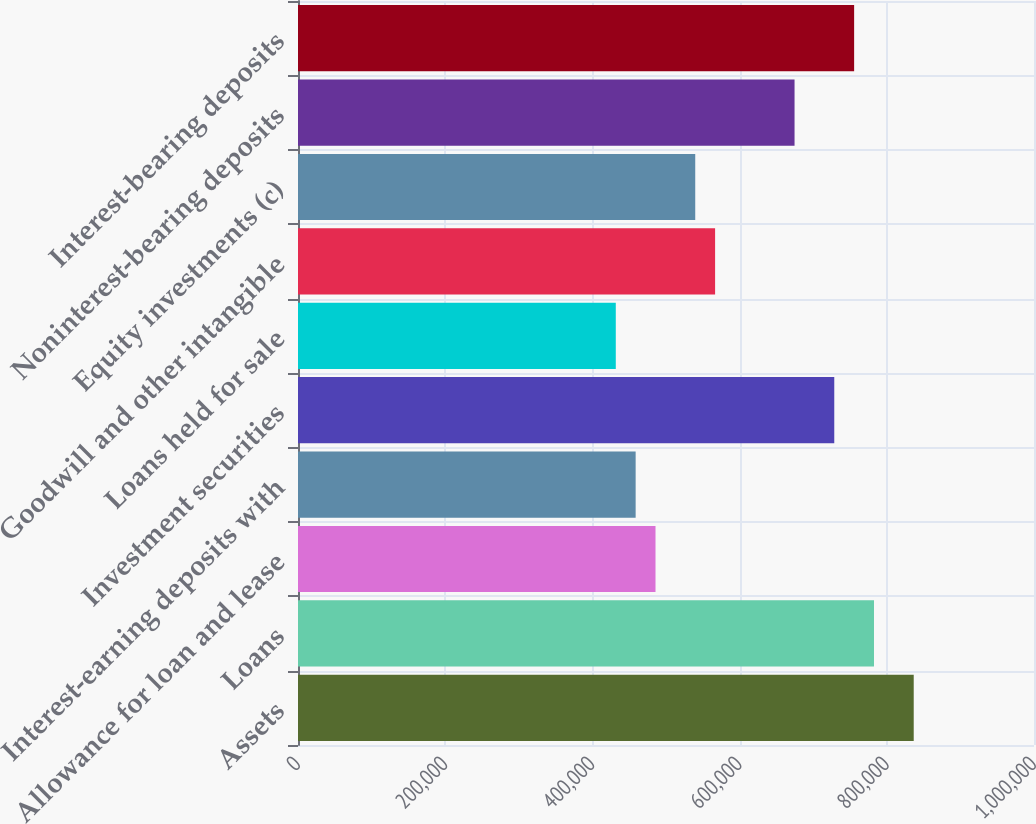<chart> <loc_0><loc_0><loc_500><loc_500><bar_chart><fcel>Assets<fcel>Loans<fcel>Allowance for loan and lease<fcel>Interest-earning deposits with<fcel>Investment securities<fcel>Loans held for sale<fcel>Goodwill and other intangible<fcel>Equity investments (c)<fcel>Noninterest-bearing deposits<fcel>Interest-bearing deposits<nl><fcel>836573<fcel>782601<fcel>485753<fcel>458766<fcel>728629<fcel>431780<fcel>566711<fcel>539725<fcel>674656<fcel>755615<nl></chart> 